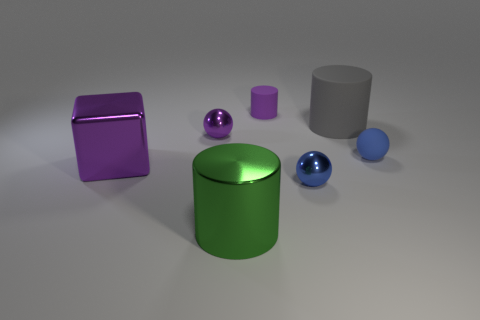Are there the same number of large things that are on the right side of the large purple shiny block and large purple shiny things?
Provide a short and direct response. No. The tiny purple metal thing has what shape?
Provide a succinct answer. Sphere. Is there any other thing that is the same color as the metallic cylinder?
Make the answer very short. No. Is the size of the matte thing that is in front of the gray object the same as the blue metal object on the right side of the purple shiny cube?
Ensure brevity in your answer.  Yes. There is a big object in front of the shiny thing that is on the right side of the green shiny object; what shape is it?
Provide a short and direct response. Cylinder. There is a blue rubber sphere; is it the same size as the blue thing that is left of the big gray thing?
Provide a succinct answer. Yes. There is a gray object behind the blue sphere behind the metal object that is to the right of the large green metal object; what is its size?
Provide a succinct answer. Large. What number of objects are large cylinders that are in front of the large gray cylinder or tiny blue matte spheres?
Offer a terse response. 2. How many green cylinders are in front of the small shiny thing that is on the left side of the tiny rubber cylinder?
Make the answer very short. 1. Is the number of balls that are behind the purple rubber object greater than the number of rubber objects?
Your answer should be compact. No. 